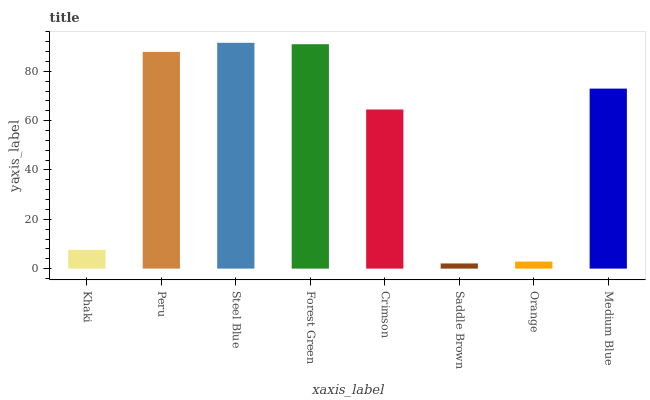Is Saddle Brown the minimum?
Answer yes or no. Yes. Is Steel Blue the maximum?
Answer yes or no. Yes. Is Peru the minimum?
Answer yes or no. No. Is Peru the maximum?
Answer yes or no. No. Is Peru greater than Khaki?
Answer yes or no. Yes. Is Khaki less than Peru?
Answer yes or no. Yes. Is Khaki greater than Peru?
Answer yes or no. No. Is Peru less than Khaki?
Answer yes or no. No. Is Medium Blue the high median?
Answer yes or no. Yes. Is Crimson the low median?
Answer yes or no. Yes. Is Forest Green the high median?
Answer yes or no. No. Is Orange the low median?
Answer yes or no. No. 